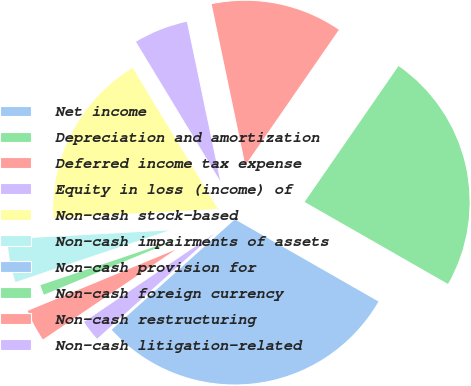Convert chart. <chart><loc_0><loc_0><loc_500><loc_500><pie_chart><fcel>Net income<fcel>Depreciation and amortization<fcel>Deferred income tax expense<fcel>Equity in loss (income) of<fcel>Non-cash stock-based<fcel>Non-cash impairments of assets<fcel>Non-cash provision for<fcel>Non-cash foreign currency<fcel>Non-cash restructuring<fcel>Non-cash litigation-related<nl><fcel>30.1%<fcel>23.65%<fcel>12.9%<fcel>5.38%<fcel>17.2%<fcel>4.3%<fcel>0.0%<fcel>1.08%<fcel>3.23%<fcel>2.15%<nl></chart> 